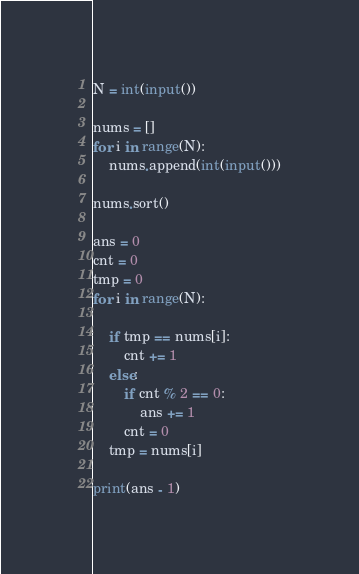<code> <loc_0><loc_0><loc_500><loc_500><_Python_>N = int(input())

nums = []
for i in range(N):
    nums.append(int(input()))

nums.sort()

ans = 0
cnt = 0
tmp = 0
for i in range(N):

    if tmp == nums[i]:
        cnt += 1
    else:
        if cnt % 2 == 0:
            ans += 1
        cnt = 0
    tmp = nums[i]

print(ans - 1)
</code> 